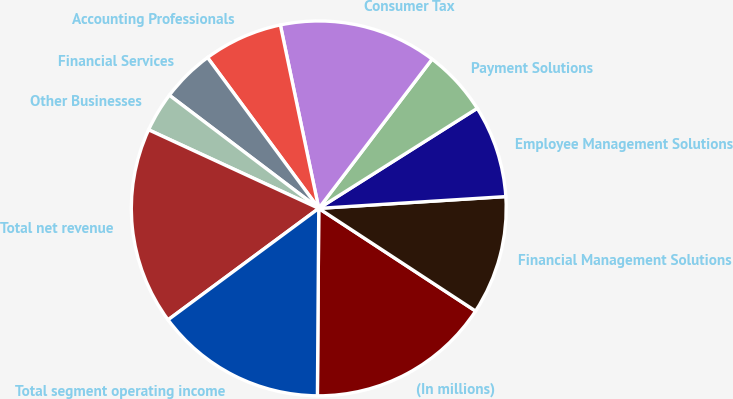Convert chart to OTSL. <chart><loc_0><loc_0><loc_500><loc_500><pie_chart><fcel>(In millions)<fcel>Financial Management Solutions<fcel>Employee Management Solutions<fcel>Payment Solutions<fcel>Consumer Tax<fcel>Accounting Professionals<fcel>Financial Services<fcel>Other Businesses<fcel>Total net revenue<fcel>Total segment operating income<nl><fcel>15.89%<fcel>10.23%<fcel>7.96%<fcel>5.7%<fcel>13.62%<fcel>6.83%<fcel>4.57%<fcel>3.43%<fcel>17.02%<fcel>14.75%<nl></chart> 